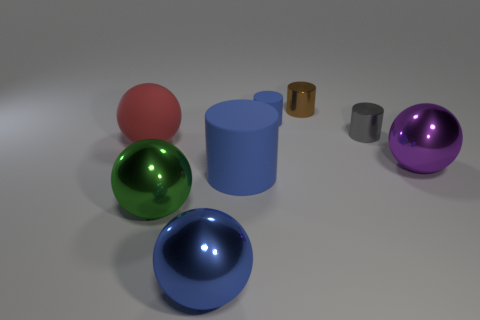Subtract 1 cylinders. How many cylinders are left? 3 Add 2 large rubber cylinders. How many objects exist? 10 Add 7 small shiny objects. How many small shiny objects exist? 9 Subtract 0 gray balls. How many objects are left? 8 Subtract all small blue rubber objects. Subtract all tiny yellow rubber cubes. How many objects are left? 7 Add 6 big green shiny things. How many big green shiny things are left? 7 